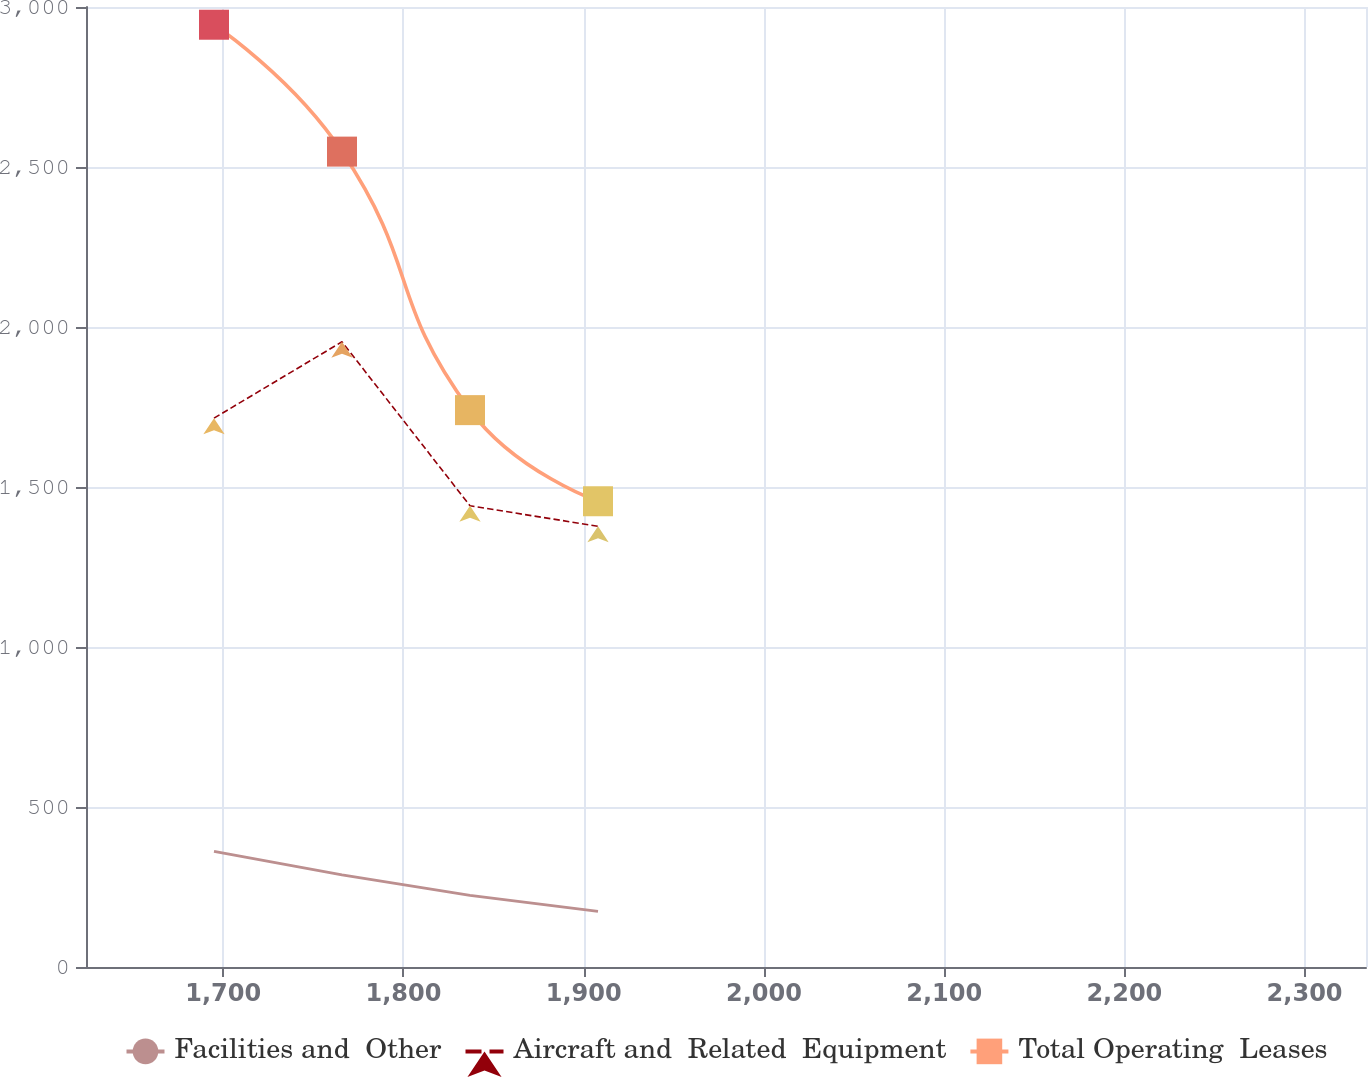<chart> <loc_0><loc_0><loc_500><loc_500><line_chart><ecel><fcel>Facilities and  Other<fcel>Aircraft and  Related  Equipment<fcel>Total Operating  Leases<nl><fcel>1694.86<fcel>361.28<fcel>1715.15<fcel>2944.6<nl><fcel>1765.88<fcel>287.8<fcel>1953.73<fcel>2548.08<nl><fcel>1836.91<fcel>223.97<fcel>1441.32<fcel>1740.21<nl><fcel>1907.94<fcel>173.86<fcel>1377.27<fcel>1455.46<nl><fcel>2405.11<fcel>112.2<fcel>1313.22<fcel>1290<nl></chart> 